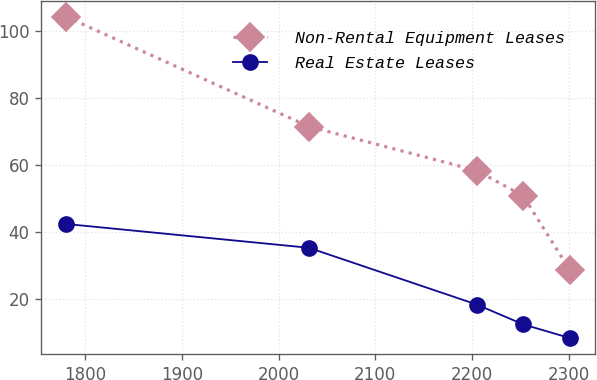Convert chart to OTSL. <chart><loc_0><loc_0><loc_500><loc_500><line_chart><ecel><fcel>Non-Rental Equipment Leases<fcel>Real Estate Leases<nl><fcel>1780.32<fcel>104.39<fcel>42.37<nl><fcel>2031.37<fcel>71.55<fcel>35.25<nl><fcel>2205.13<fcel>58.35<fcel>18.25<nl><fcel>2253.17<fcel>50.77<fcel>12.32<nl><fcel>2301.21<fcel>28.63<fcel>8.25<nl></chart> 